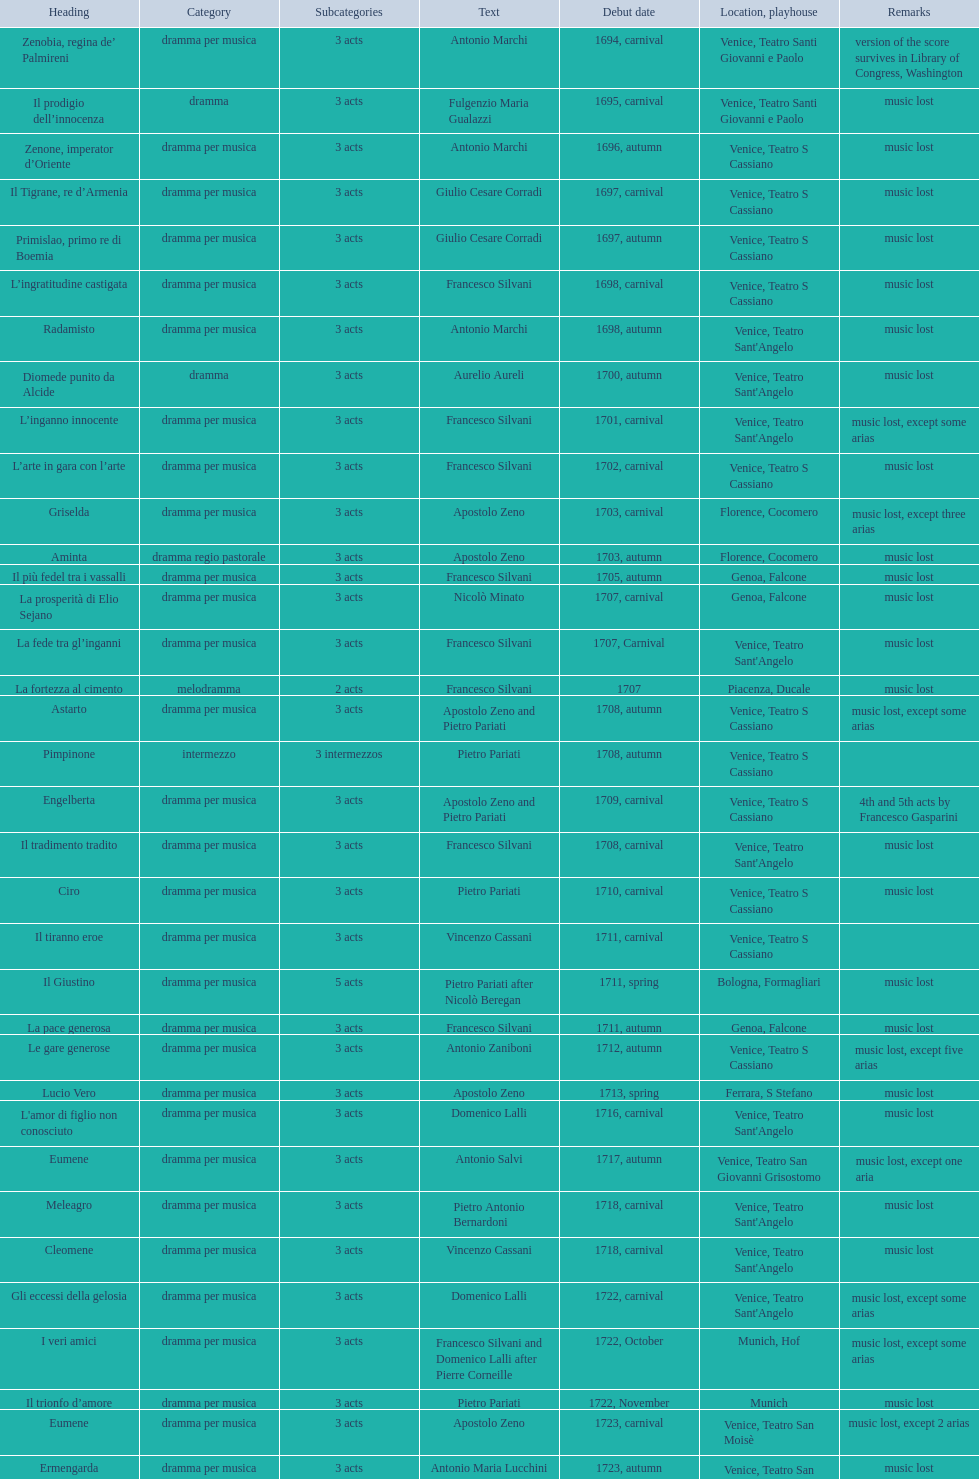How many operas on this list have 3 or more acts? 51. 